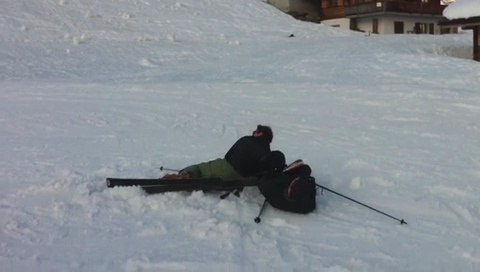Describe the objects in this image and their specific colors. I can see people in darkgray, black, and gray tones, backpack in darkgray, black, and gray tones, people in darkgray, black, and gray tones, and skis in darkgray, black, and gray tones in this image. 